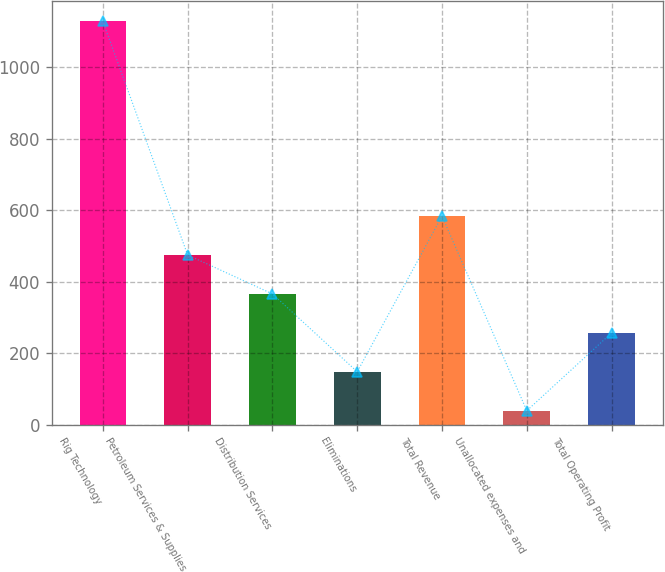Convert chart to OTSL. <chart><loc_0><loc_0><loc_500><loc_500><bar_chart><fcel>Rig Technology<fcel>Petroleum Services & Supplies<fcel>Distribution Services<fcel>Eliminations<fcel>Total Revenue<fcel>Unallocated expenses and<fcel>Total Operating Profit<nl><fcel>1128<fcel>474.6<fcel>365.7<fcel>147.9<fcel>583.5<fcel>39<fcel>256.8<nl></chart> 